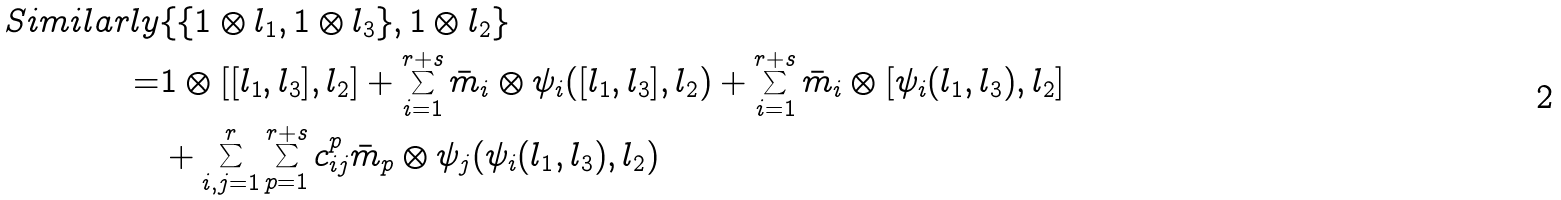Convert formula to latex. <formula><loc_0><loc_0><loc_500><loc_500>S i m i l a r l y & \{ \{ 1 \otimes l _ { 1 } , 1 \otimes l _ { 3 } \} , 1 \otimes l _ { 2 } \} \\ = & 1 \otimes [ [ l _ { 1 } , l _ { 3 } ] , l _ { 2 } ] + \sum _ { i = 1 } ^ { r + s } \bar { m } _ { i } \otimes \psi _ { i } ( [ l _ { 1 } , l _ { 3 } ] , l _ { 2 } ) + \sum _ { i = 1 } ^ { r + s } \bar { m } _ { i } \otimes [ \psi _ { i } ( l _ { 1 } , l _ { 3 } ) , l _ { 2 } ] \\ & + \sum _ { i , j = 1 } ^ { r } \sum _ { p = 1 } ^ { r + s } c _ { i j } ^ { p } \bar { m } _ { p } \otimes \psi _ { j } ( \psi _ { i } ( l _ { 1 } , l _ { 3 } ) , l _ { 2 } )</formula> 